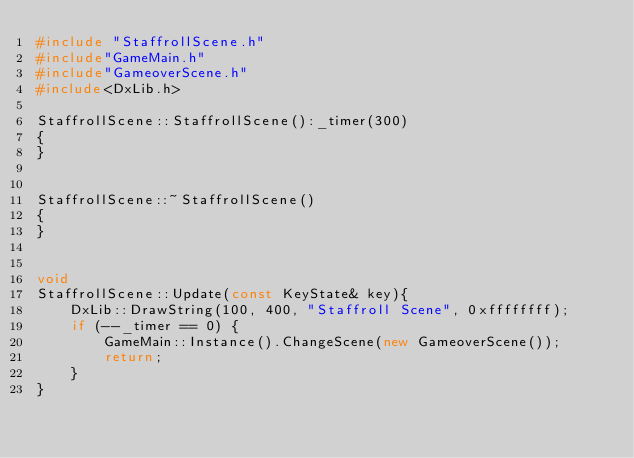<code> <loc_0><loc_0><loc_500><loc_500><_C++_>#include "StaffrollScene.h"
#include"GameMain.h"
#include"GameoverScene.h"
#include<DxLib.h>

StaffrollScene::StaffrollScene():_timer(300)
{
}


StaffrollScene::~StaffrollScene()
{
}


void
StaffrollScene::Update(const KeyState& key){
	DxLib::DrawString(100, 400, "Staffroll Scene", 0xffffffff);
	if (--_timer == 0) {
		GameMain::Instance().ChangeScene(new GameoverScene());
		return;
	}
}
</code> 